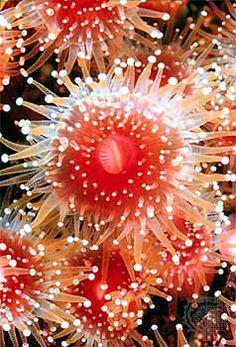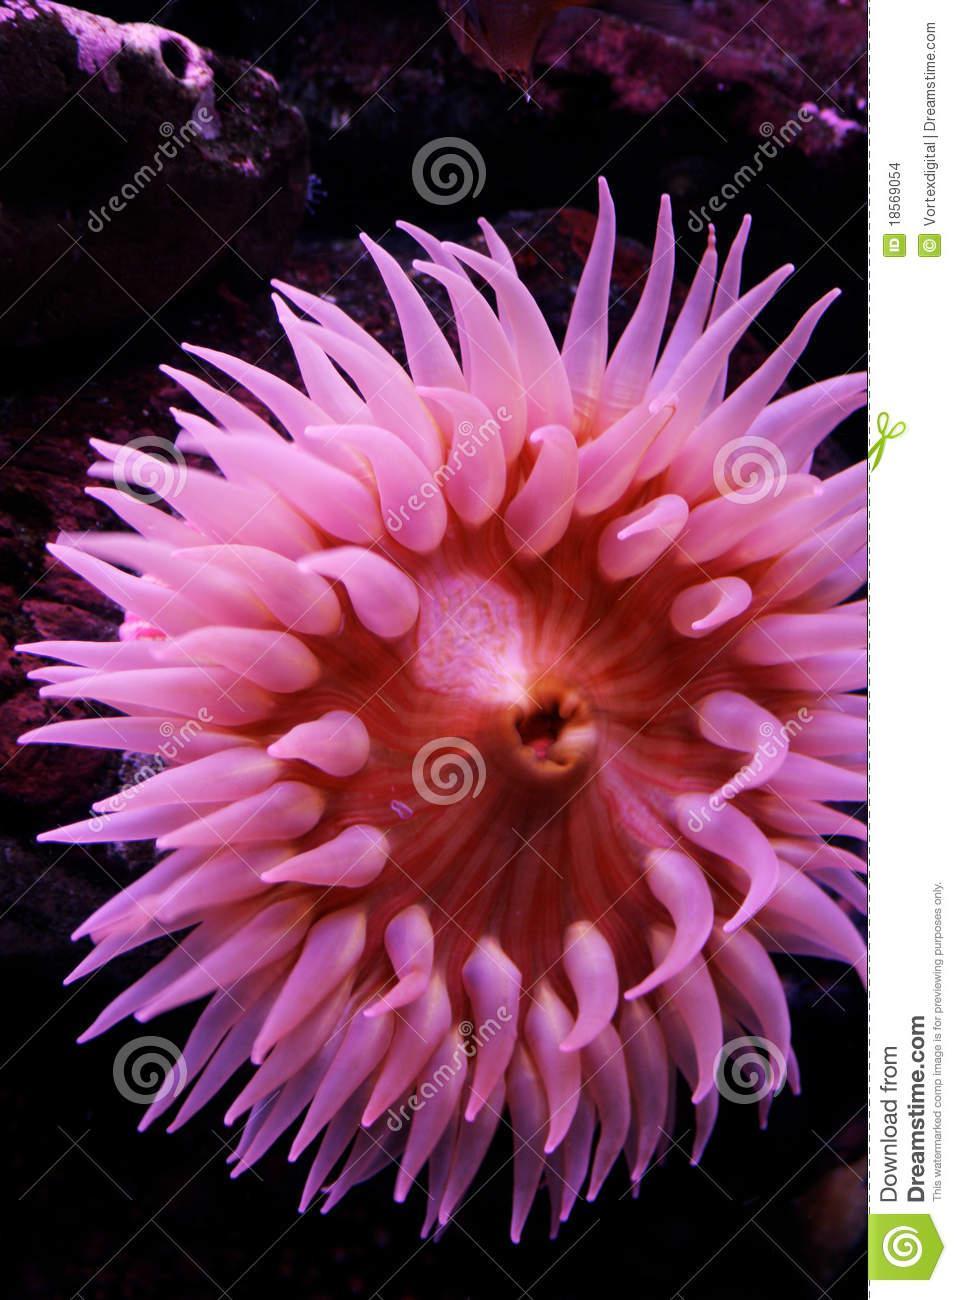The first image is the image on the left, the second image is the image on the right. Assess this claim about the two images: "An image shows an anemone with lavender tendrils that taper distinctly.". Correct or not? Answer yes or no. Yes. The first image is the image on the left, the second image is the image on the right. Examine the images to the left and right. Is the description "One of the sea creatures is yellowish in color and the other is pink." accurate? Answer yes or no. No. 